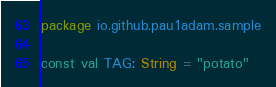<code> <loc_0><loc_0><loc_500><loc_500><_Kotlin_>package io.github.pau1adam.sample

const val TAG: String = "potato"</code> 